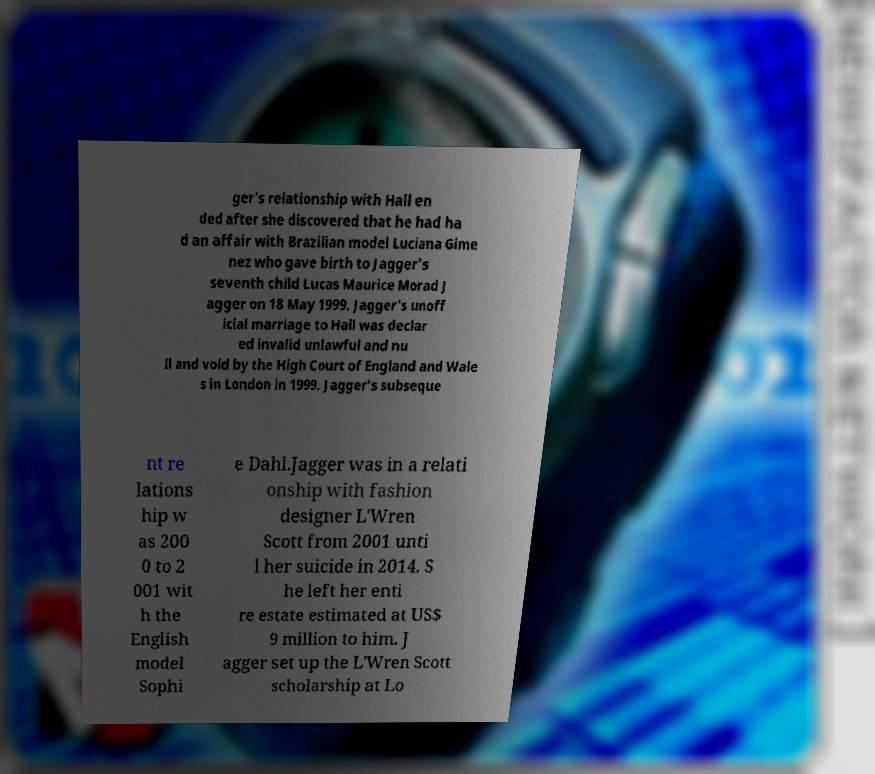Could you assist in decoding the text presented in this image and type it out clearly? ger's relationship with Hall en ded after she discovered that he had ha d an affair with Brazilian model Luciana Gime nez who gave birth to Jagger's seventh child Lucas Maurice Morad J agger on 18 May 1999. Jagger's unoff icial marriage to Hall was declar ed invalid unlawful and nu ll and void by the High Court of England and Wale s in London in 1999. Jagger's subseque nt re lations hip w as 200 0 to 2 001 wit h the English model Sophi e Dahl.Jagger was in a relati onship with fashion designer L'Wren Scott from 2001 unti l her suicide in 2014. S he left her enti re estate estimated at US$ 9 million to him. J agger set up the L'Wren Scott scholarship at Lo 